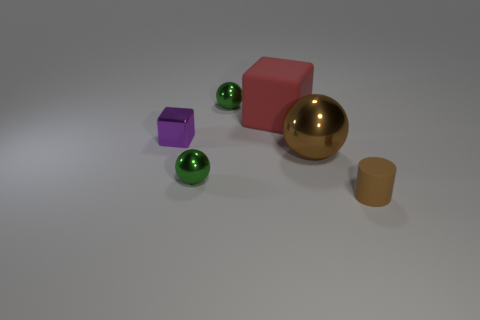Subtract all large spheres. How many spheres are left? 2 Subtract all brown spheres. How many spheres are left? 2 Add 4 green metal spheres. How many objects exist? 10 Subtract all purple cylinders. How many green balls are left? 2 Subtract 2 spheres. How many spheres are left? 1 Add 1 large metal things. How many large metal things are left? 2 Add 4 large gray rubber spheres. How many large gray rubber spheres exist? 4 Subtract 0 blue balls. How many objects are left? 6 Subtract all cylinders. How many objects are left? 5 Subtract all cyan blocks. Subtract all brown spheres. How many blocks are left? 2 